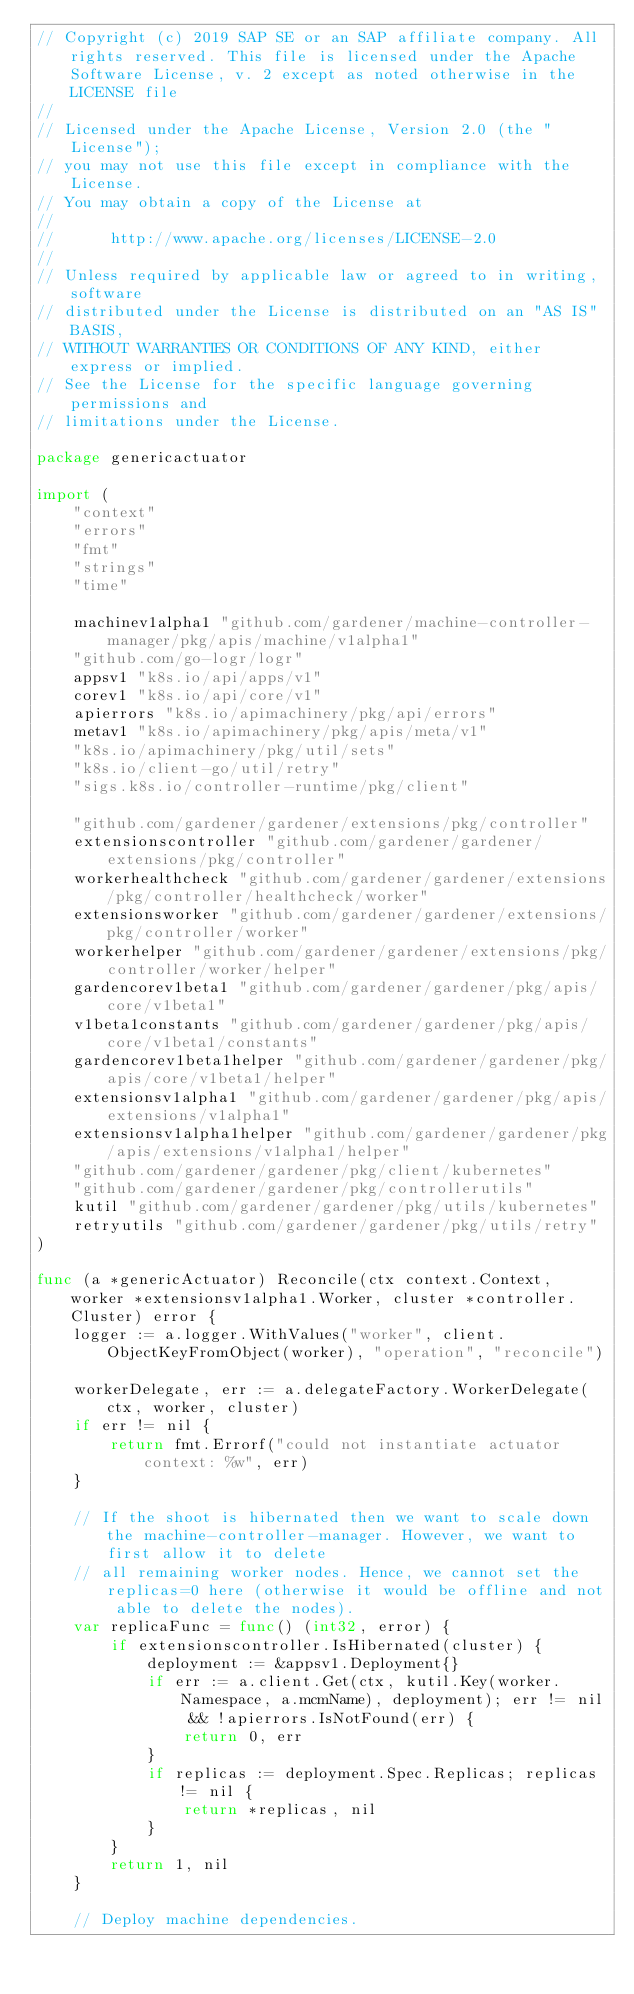<code> <loc_0><loc_0><loc_500><loc_500><_Go_>// Copyright (c) 2019 SAP SE or an SAP affiliate company. All rights reserved. This file is licensed under the Apache Software License, v. 2 except as noted otherwise in the LICENSE file
//
// Licensed under the Apache License, Version 2.0 (the "License");
// you may not use this file except in compliance with the License.
// You may obtain a copy of the License at
//
//      http://www.apache.org/licenses/LICENSE-2.0
//
// Unless required by applicable law or agreed to in writing, software
// distributed under the License is distributed on an "AS IS" BASIS,
// WITHOUT WARRANTIES OR CONDITIONS OF ANY KIND, either express or implied.
// See the License for the specific language governing permissions and
// limitations under the License.

package genericactuator

import (
	"context"
	"errors"
	"fmt"
	"strings"
	"time"

	machinev1alpha1 "github.com/gardener/machine-controller-manager/pkg/apis/machine/v1alpha1"
	"github.com/go-logr/logr"
	appsv1 "k8s.io/api/apps/v1"
	corev1 "k8s.io/api/core/v1"
	apierrors "k8s.io/apimachinery/pkg/api/errors"
	metav1 "k8s.io/apimachinery/pkg/apis/meta/v1"
	"k8s.io/apimachinery/pkg/util/sets"
	"k8s.io/client-go/util/retry"
	"sigs.k8s.io/controller-runtime/pkg/client"

	"github.com/gardener/gardener/extensions/pkg/controller"
	extensionscontroller "github.com/gardener/gardener/extensions/pkg/controller"
	workerhealthcheck "github.com/gardener/gardener/extensions/pkg/controller/healthcheck/worker"
	extensionsworker "github.com/gardener/gardener/extensions/pkg/controller/worker"
	workerhelper "github.com/gardener/gardener/extensions/pkg/controller/worker/helper"
	gardencorev1beta1 "github.com/gardener/gardener/pkg/apis/core/v1beta1"
	v1beta1constants "github.com/gardener/gardener/pkg/apis/core/v1beta1/constants"
	gardencorev1beta1helper "github.com/gardener/gardener/pkg/apis/core/v1beta1/helper"
	extensionsv1alpha1 "github.com/gardener/gardener/pkg/apis/extensions/v1alpha1"
	extensionsv1alpha1helper "github.com/gardener/gardener/pkg/apis/extensions/v1alpha1/helper"
	"github.com/gardener/gardener/pkg/client/kubernetes"
	"github.com/gardener/gardener/pkg/controllerutils"
	kutil "github.com/gardener/gardener/pkg/utils/kubernetes"
	retryutils "github.com/gardener/gardener/pkg/utils/retry"
)

func (a *genericActuator) Reconcile(ctx context.Context, worker *extensionsv1alpha1.Worker, cluster *controller.Cluster) error {
	logger := a.logger.WithValues("worker", client.ObjectKeyFromObject(worker), "operation", "reconcile")

	workerDelegate, err := a.delegateFactory.WorkerDelegate(ctx, worker, cluster)
	if err != nil {
		return fmt.Errorf("could not instantiate actuator context: %w", err)
	}

	// If the shoot is hibernated then we want to scale down the machine-controller-manager. However, we want to first allow it to delete
	// all remaining worker nodes. Hence, we cannot set the replicas=0 here (otherwise it would be offline and not able to delete the nodes).
	var replicaFunc = func() (int32, error) {
		if extensionscontroller.IsHibernated(cluster) {
			deployment := &appsv1.Deployment{}
			if err := a.client.Get(ctx, kutil.Key(worker.Namespace, a.mcmName), deployment); err != nil && !apierrors.IsNotFound(err) {
				return 0, err
			}
			if replicas := deployment.Spec.Replicas; replicas != nil {
				return *replicas, nil
			}
		}
		return 1, nil
	}

	// Deploy machine dependencies.</code> 